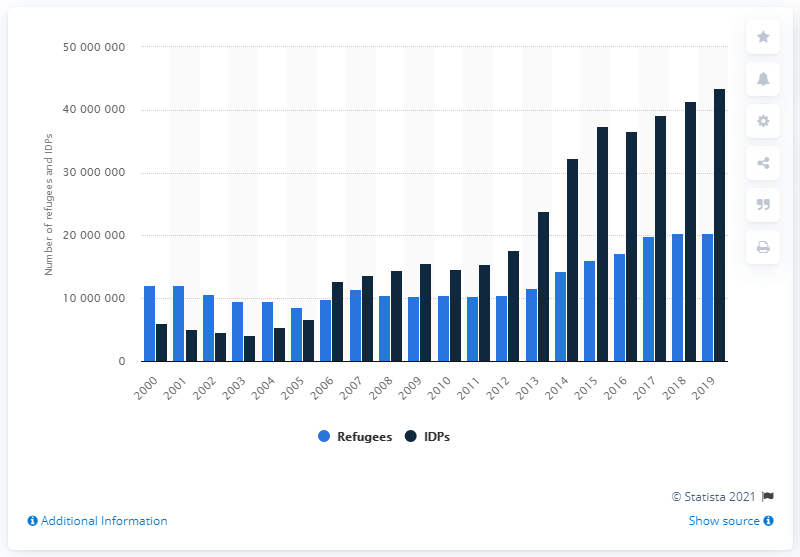Indicate a few pertinent items in this graphic. In 2019, the United Nations registered a total of 204,448 refugees. In 2019, the United Nations registered a total of 4,142,516 IDPs (Internally Displaced Persons). According to the United Nations, a total of 41,425,168 individuals were registered as internationally displaced persons in 2019. 